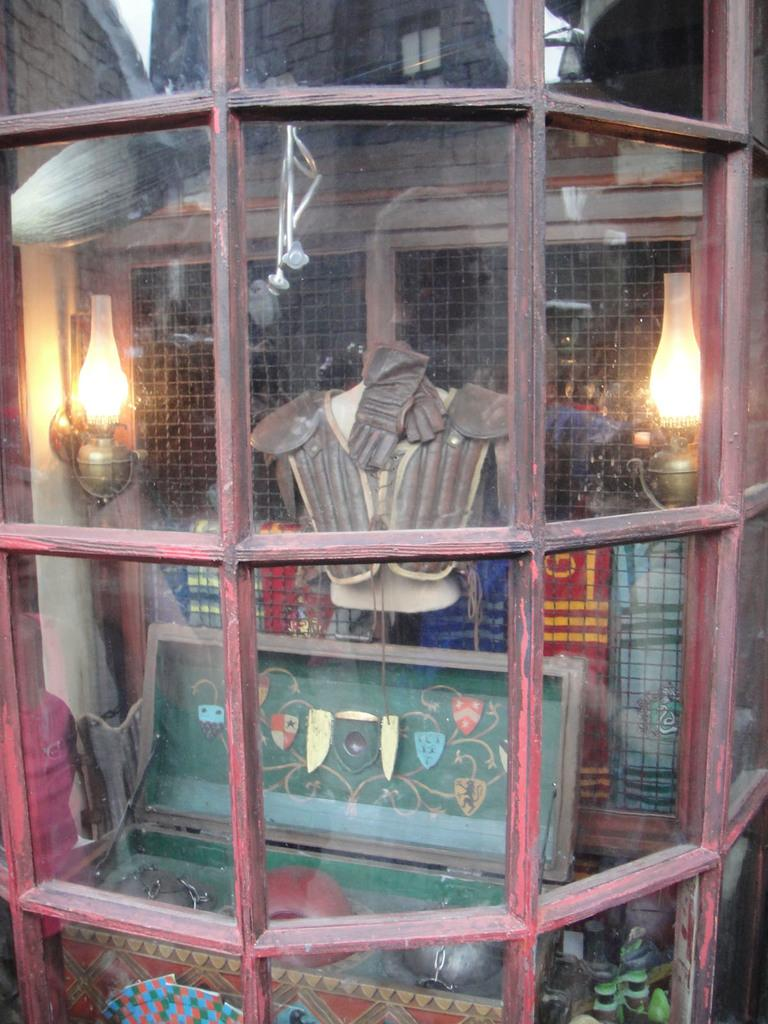What type of protective gear is visible in the image? There is armor in the image. What other object can be seen in the image? There is a box in the image. Can you describe the light source in the image? The light is placed in a glass shell. What type of material is present in the background of the image? There is a mesh in the background of the image. What type of song is being played by the tiger in the image? There is no tiger present in the image, and therefore no song can be heard. Can you describe the kettle in the image? There is no kettle present in the image. 